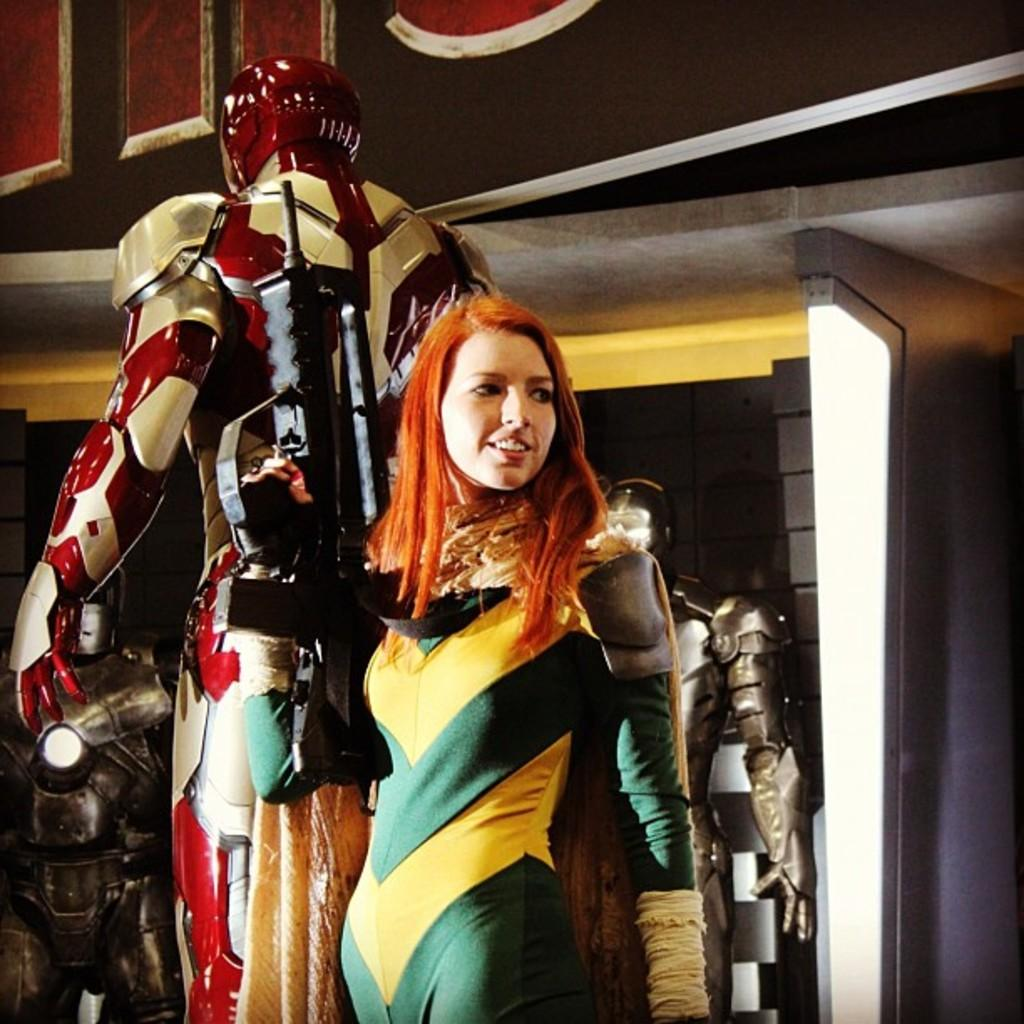Who is present in the image? There is a woman in the image. What is the woman doing in the image? The woman is standing in the image. What is the woman holding in her hand? The woman is holding a gun in her hand. What other objects can be seen in the image? There are objects in the image that resemble robots. What type of cart can be seen in the image? There is no cart present in the image. Is there any snow visible in the image? There is no snow visible in the image. 